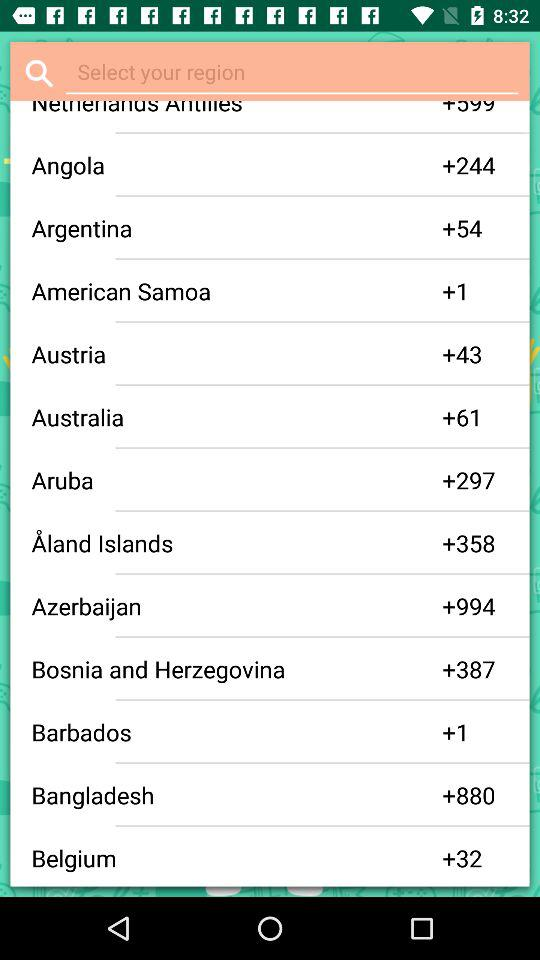What is the code for the Belgium region? The Belgium region code is +32. 